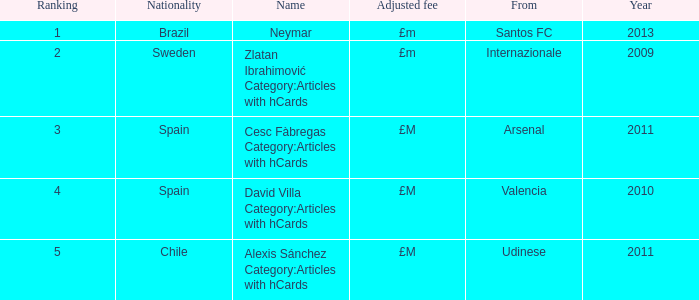What is the country of origin for the player ranked number 2? Internazionale. 